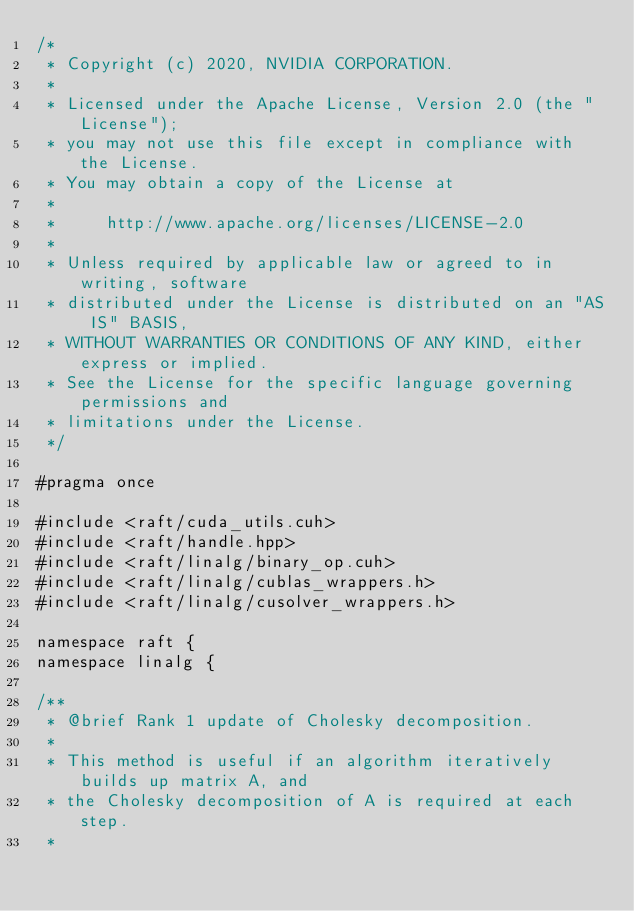Convert code to text. <code><loc_0><loc_0><loc_500><loc_500><_Cuda_>/*
 * Copyright (c) 2020, NVIDIA CORPORATION.
 *
 * Licensed under the Apache License, Version 2.0 (the "License");
 * you may not use this file except in compliance with the License.
 * You may obtain a copy of the License at
 *
 *     http://www.apache.org/licenses/LICENSE-2.0
 *
 * Unless required by applicable law or agreed to in writing, software
 * distributed under the License is distributed on an "AS IS" BASIS,
 * WITHOUT WARRANTIES OR CONDITIONS OF ANY KIND, either express or implied.
 * See the License for the specific language governing permissions and
 * limitations under the License.
 */

#pragma once

#include <raft/cuda_utils.cuh>
#include <raft/handle.hpp>
#include <raft/linalg/binary_op.cuh>
#include <raft/linalg/cublas_wrappers.h>
#include <raft/linalg/cusolver_wrappers.h>

namespace raft {
namespace linalg {

/**
 * @brief Rank 1 update of Cholesky decomposition.
 *
 * This method is useful if an algorithm iteratively builds up matrix A, and
 * the Cholesky decomposition of A is required at each step.
 *</code> 